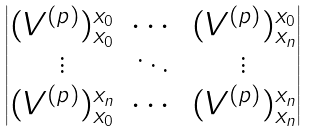<formula> <loc_0><loc_0><loc_500><loc_500>\begin{vmatrix} ( V ^ { ( p ) } ) ^ { x _ { 0 } } _ { x _ { 0 } } & \cdots & ( V ^ { ( p ) } ) ^ { x _ { 0 } } _ { x _ { n } } \\ \vdots & \ddots & \vdots \\ ( V ^ { ( p ) } ) ^ { x _ { n } } _ { x _ { 0 } } & \cdots & ( V ^ { ( p ) } ) ^ { x _ { n } } _ { x _ { n } } \end{vmatrix}</formula> 